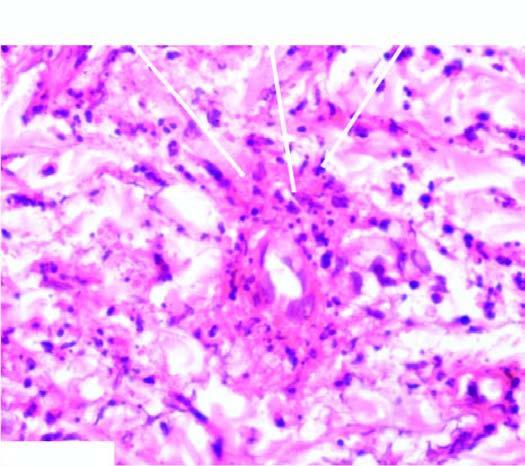what shows fibrinoid necrosis surrounded by viable as well as fragmented neutrophils?
Answer the question using a single word or phrase. The vessel wall 